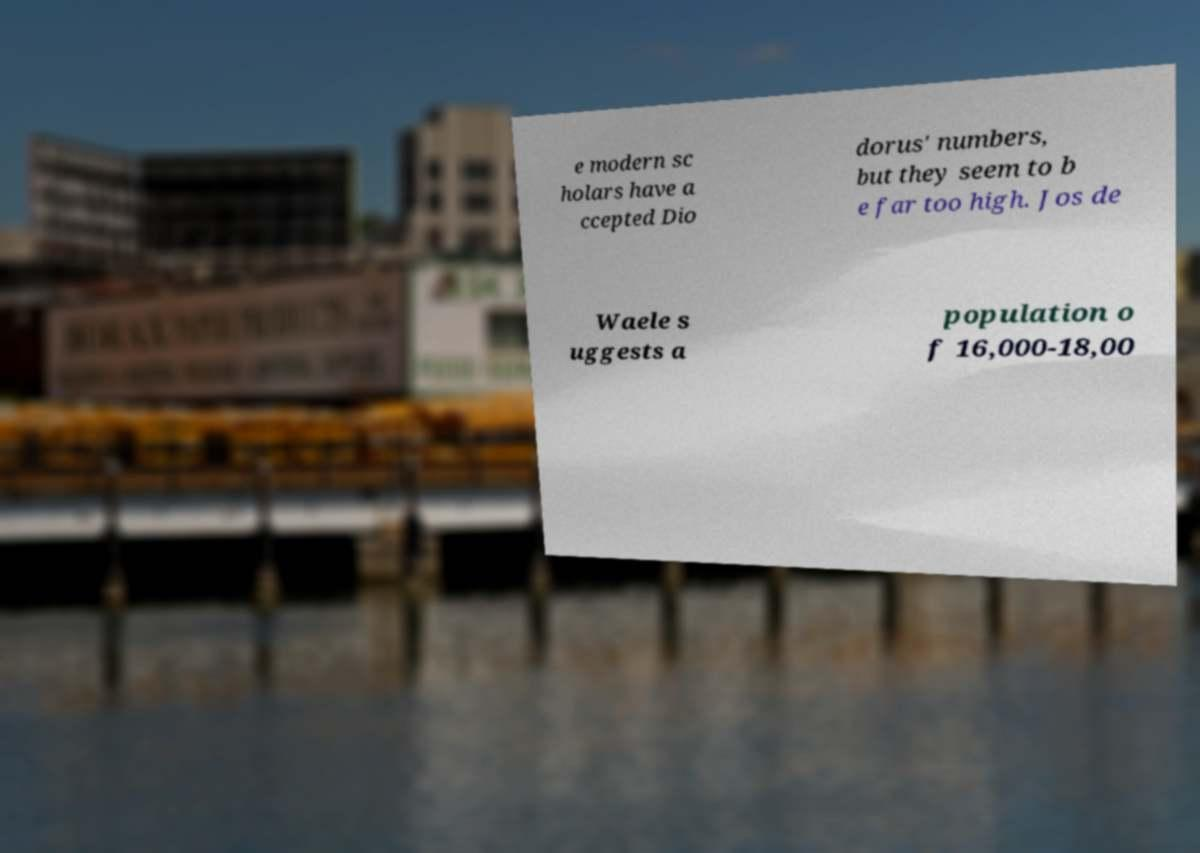Can you read and provide the text displayed in the image?This photo seems to have some interesting text. Can you extract and type it out for me? e modern sc holars have a ccepted Dio dorus' numbers, but they seem to b e far too high. Jos de Waele s uggests a population o f 16,000-18,00 